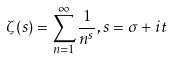Convert formula to latex. <formula><loc_0><loc_0><loc_500><loc_500>\zeta ( s ) = \sum _ { n = 1 } ^ { \infty } \frac { 1 } { n ^ { s } } , s = \sigma + i t</formula> 